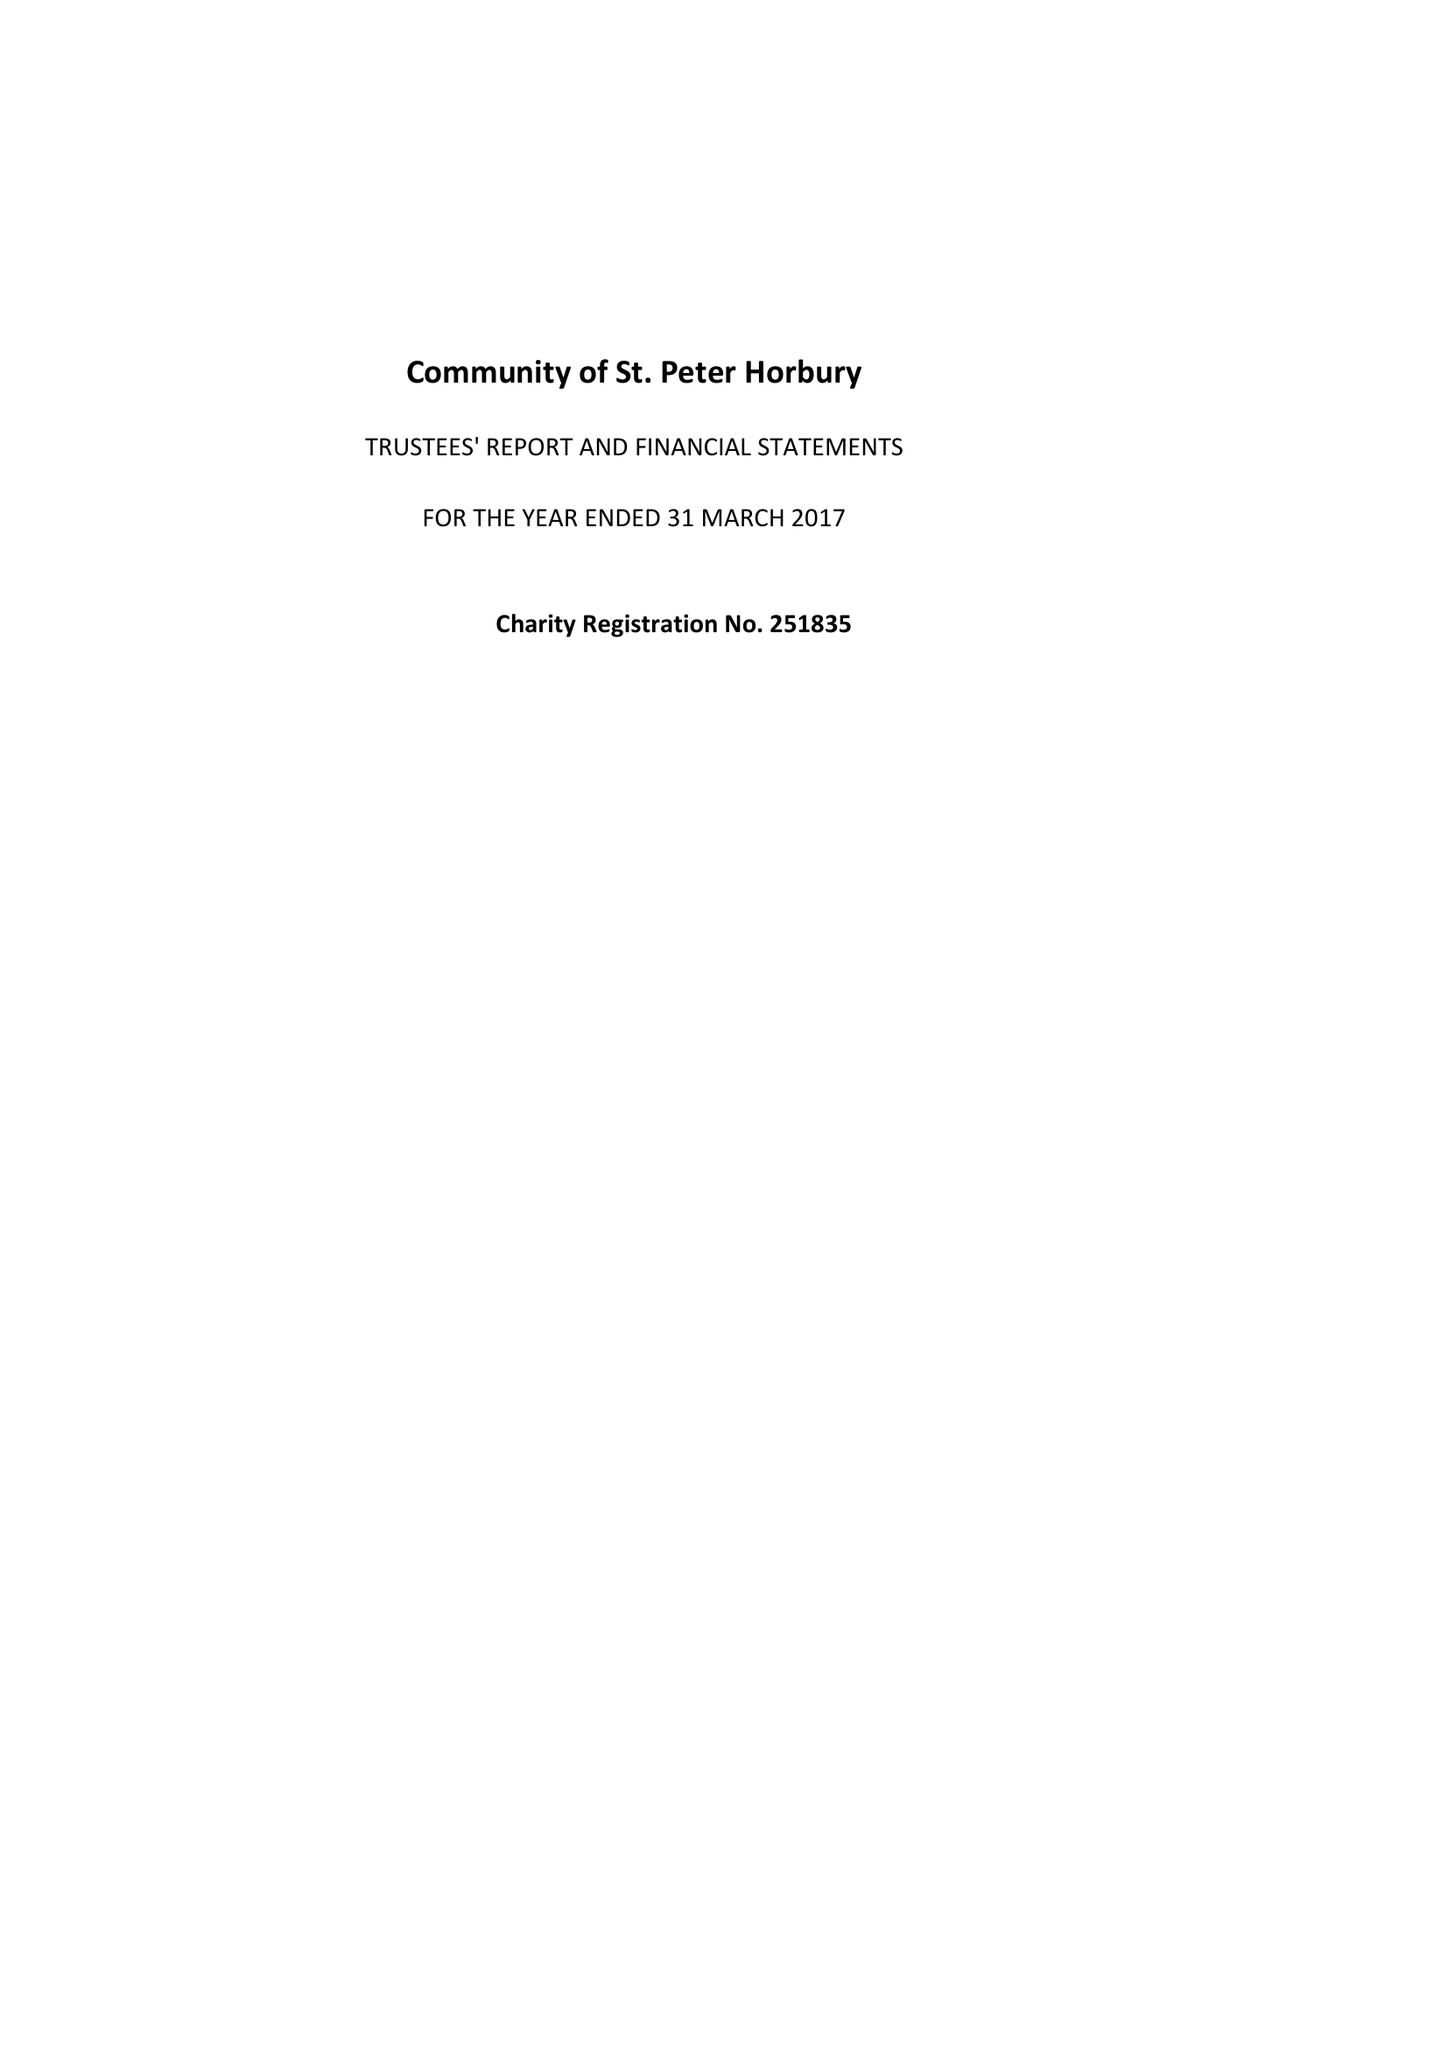What is the value for the address__post_town?
Answer the question using a single word or phrase. WAKEFIELD 